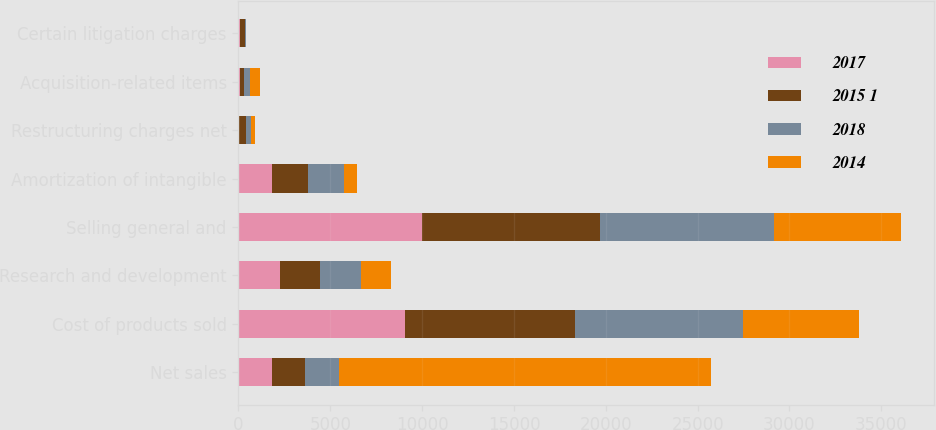Convert chart to OTSL. <chart><loc_0><loc_0><loc_500><loc_500><stacked_bar_chart><ecel><fcel>Net sales<fcel>Cost of products sold<fcel>Research and development<fcel>Selling general and<fcel>Amortization of intangible<fcel>Restructuring charges net<fcel>Acquisition-related items<fcel>Certain litigation charges<nl><fcel>2017<fcel>1823<fcel>9055<fcel>2253<fcel>9974<fcel>1823<fcel>30<fcel>104<fcel>61<nl><fcel>2015 1<fcel>1823<fcel>9291<fcel>2193<fcel>9711<fcel>1980<fcel>363<fcel>220<fcel>300<nl><fcel>2018<fcel>1823<fcel>9142<fcel>2224<fcel>9469<fcel>1931<fcel>290<fcel>283<fcel>26<nl><fcel>2014<fcel>20261<fcel>6309<fcel>1640<fcel>6904<fcel>733<fcel>237<fcel>550<fcel>42<nl></chart> 